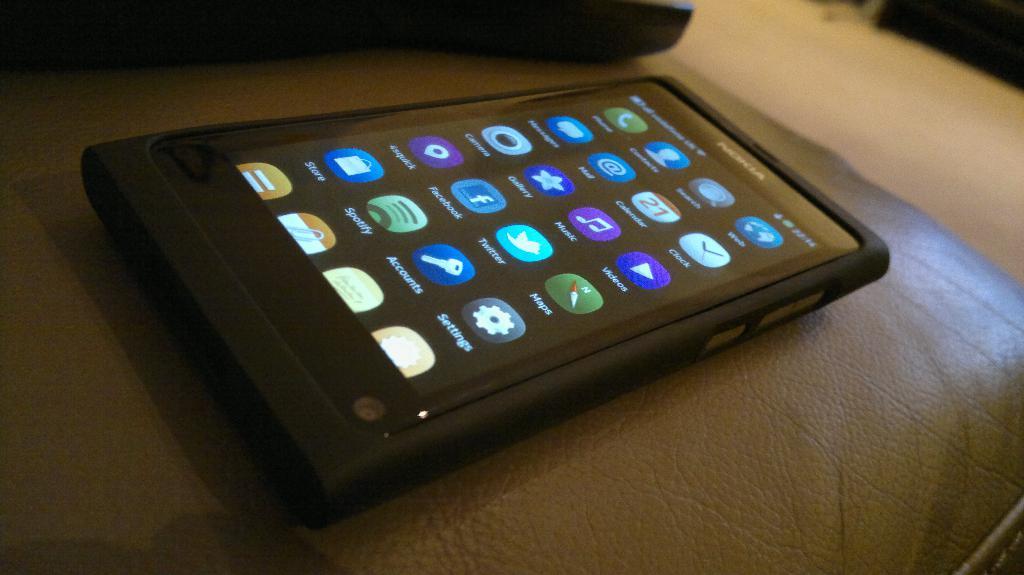What is the name of the app with a compass?
Provide a succinct answer. Maps. What is the brand of the phone?
Offer a very short reply. Nokia. 